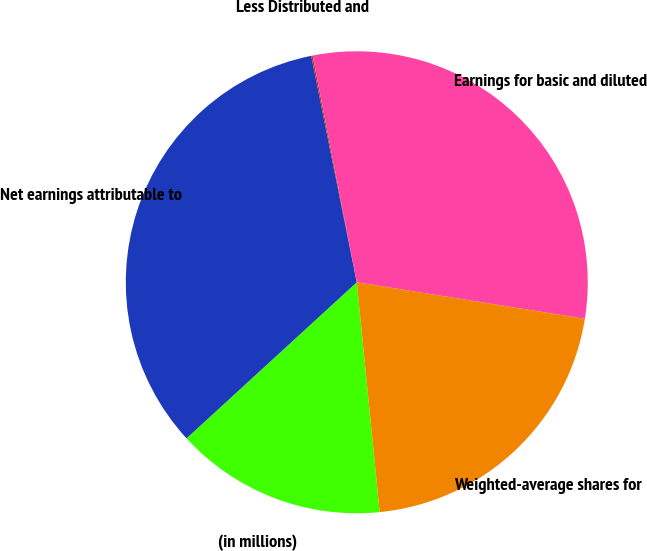<chart> <loc_0><loc_0><loc_500><loc_500><pie_chart><fcel>(in millions)<fcel>Net earnings attributable to<fcel>Less Distributed and<fcel>Earnings for basic and diluted<fcel>Weighted-average shares for<nl><fcel>14.77%<fcel>33.65%<fcel>0.1%<fcel>30.59%<fcel>20.89%<nl></chart> 